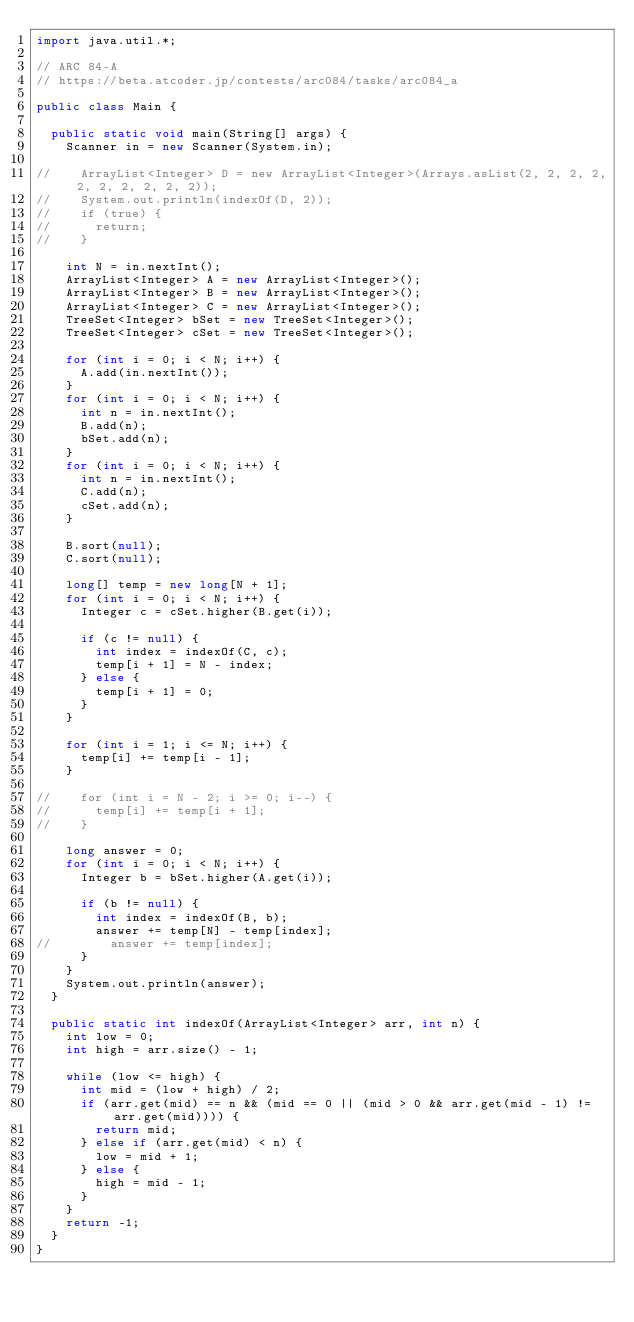Convert code to text. <code><loc_0><loc_0><loc_500><loc_500><_Java_>import java.util.*;

// ARC 84-A
// https://beta.atcoder.jp/contests/arc084/tasks/arc084_a

public class Main {
	
	public static void main(String[] args) {
		Scanner in = new Scanner(System.in);

//		ArrayList<Integer> D = new ArrayList<Integer>(Arrays.asList(2, 2, 2, 2, 2, 2, 2, 2, 2, 2));
//		System.out.println(indexOf(D, 2));
//		if (true) {
//			return;
//		}
		
		int N = in.nextInt();
		ArrayList<Integer> A = new ArrayList<Integer>();
		ArrayList<Integer> B = new ArrayList<Integer>();
		ArrayList<Integer> C = new ArrayList<Integer>();
		TreeSet<Integer> bSet = new TreeSet<Integer>();
		TreeSet<Integer> cSet = new TreeSet<Integer>();
		
		for (int i = 0; i < N; i++) {
			A.add(in.nextInt());
		}
		for (int i = 0; i < N; i++) {
			int n = in.nextInt();
			B.add(n);
			bSet.add(n);
		}
		for (int i = 0; i < N; i++) {
			int n = in.nextInt();
			C.add(n);
			cSet.add(n);
		}

		B.sort(null);
		C.sort(null);
		
		long[] temp = new long[N + 1];
		for (int i = 0; i < N; i++) {
			Integer c = cSet.higher(B.get(i));
			
			if (c != null) {
				int index = indexOf(C, c);
				temp[i + 1] = N - index;
			} else {
				temp[i + 1] = 0;
			}
		}
		
		for (int i = 1; i <= N; i++) {
			temp[i] += temp[i - 1];
		}
		
//		for (int i = N - 2; i >= 0; i--) {
//			temp[i] += temp[i + 1];
//		}
		
		long answer = 0;
		for (int i = 0; i < N; i++) {
			Integer b = bSet.higher(A.get(i));
			
			if (b != null) {
				int index = indexOf(B, b);
				answer += temp[N] - temp[index];
//				answer += temp[index];
			}
		}
		System.out.println(answer);
	}
	
	public static int indexOf(ArrayList<Integer> arr, int n) {
		int low = 0;
		int high = arr.size() - 1;
		
		while (low <= high) {
			int mid = (low + high) / 2;
			if (arr.get(mid) == n && (mid == 0 || (mid > 0 && arr.get(mid - 1) != arr.get(mid)))) {
				return mid;
			} else if (arr.get(mid) < n) {
				low = mid + 1;
			} else {
				high = mid - 1;
			}
		}
		return -1;
	}
}</code> 